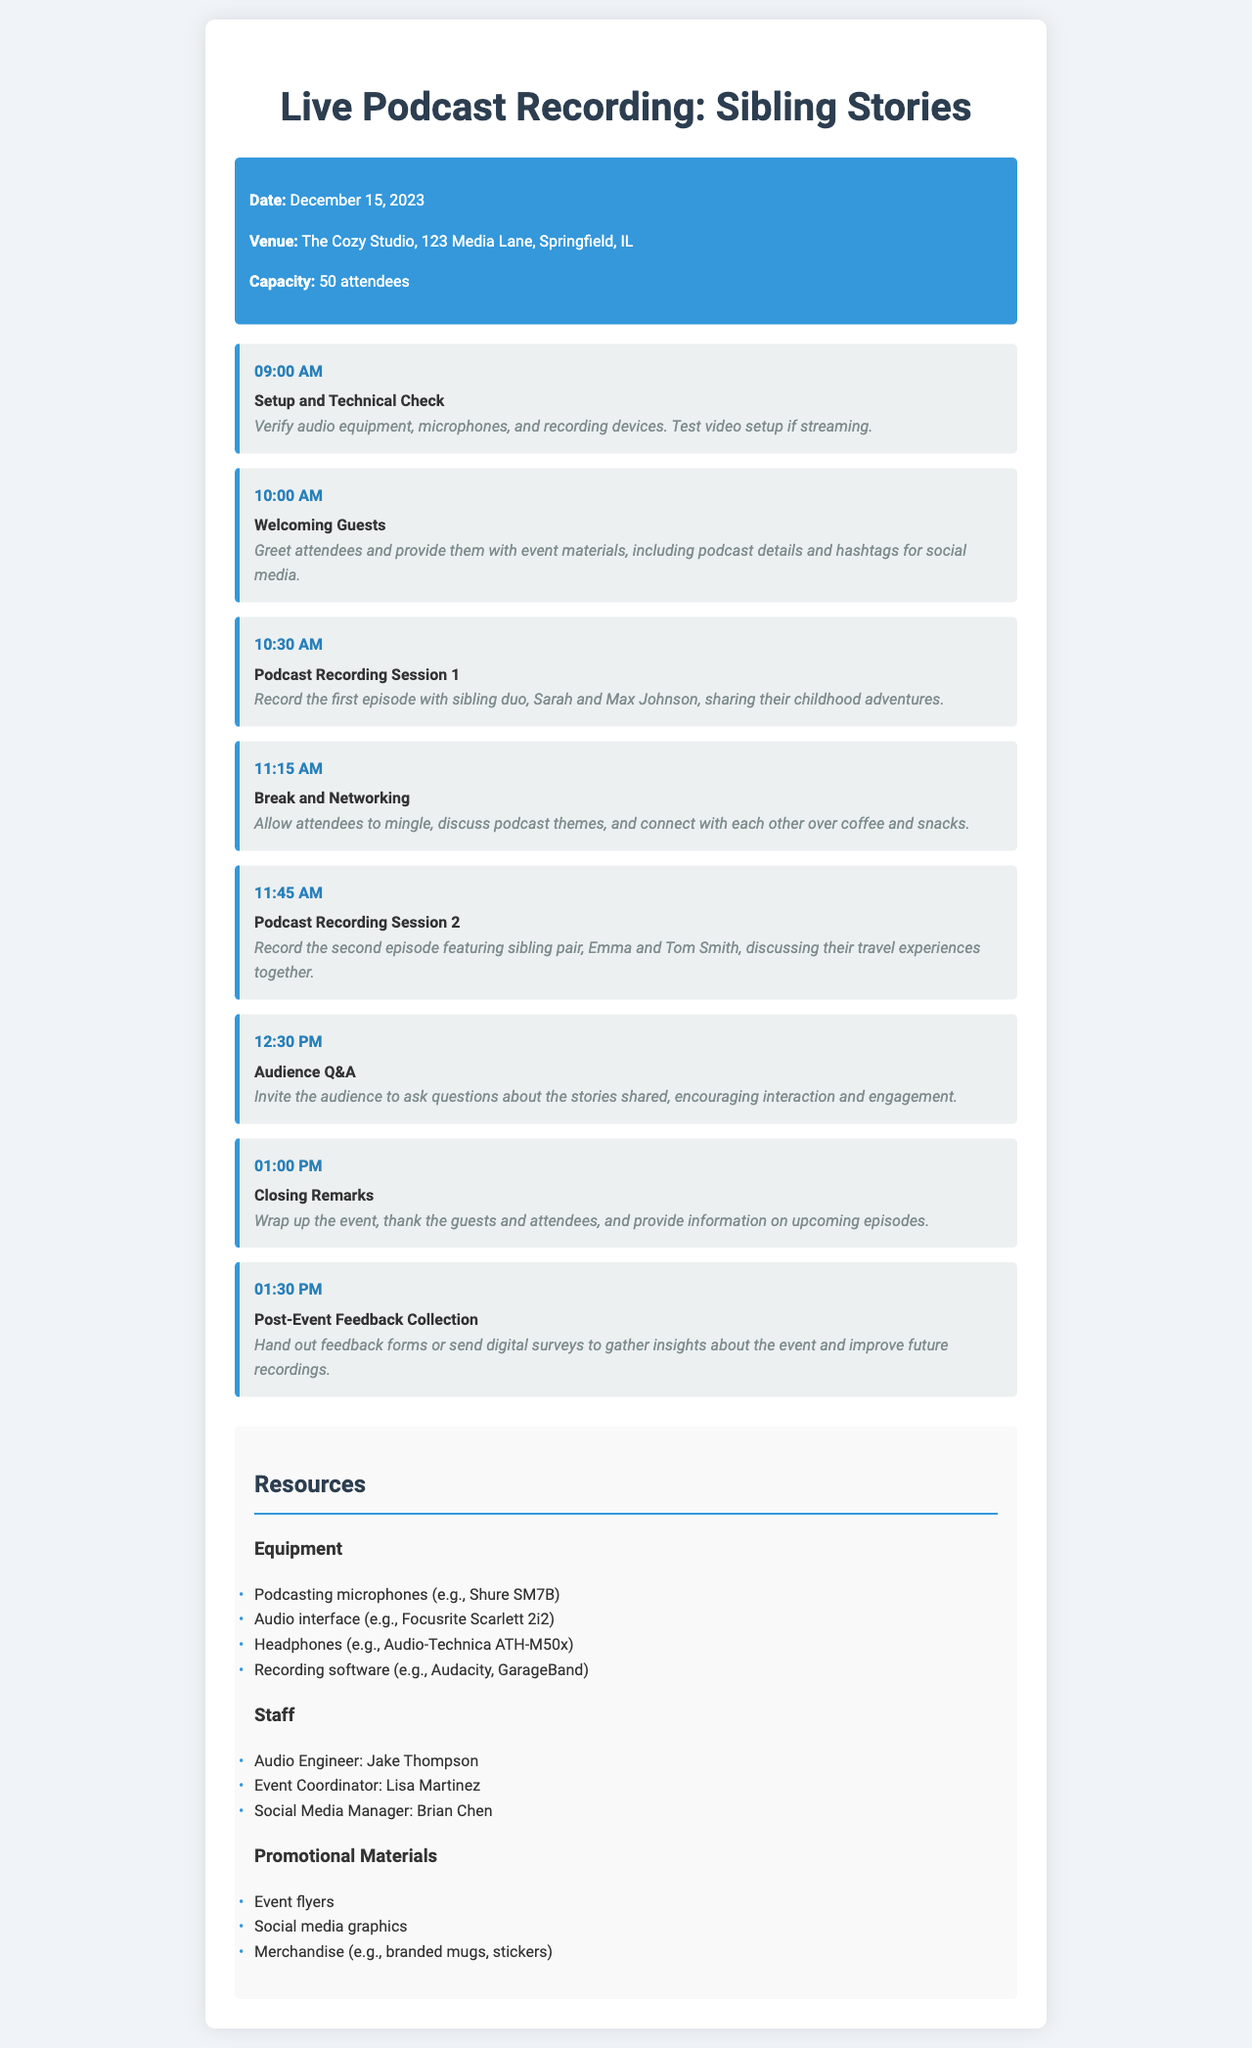What is the date of the live podcast recording? The date is specified in the event info section of the document.
Answer: December 15, 2023 Where is the venue located? The venue information is listed in the event info section.
Answer: The Cozy Studio, 123 Media Lane, Springfield, IL How many attendees can the venue accommodate? This information is provided under the event info section.
Answer: 50 attendees What is the first activity scheduled? The schedule details the activities in chronological order, starting from the beginning.
Answer: Setup and Technical Check What time does the Audience Q&A session start? The schedule lists the time for each activity in order.
Answer: 12:30 PM Who is the audio engineer for the event? Staff details are provided in the resources section of the document.
Answer: Jake Thompson What equipment is listed for recording? The resources section includes a list of equipment needed for the event.
Answer: Podcasting microphones (e.g., Shure SM7B) How long is the break and networking session? The schedule gives the duration of each session and breaks between recordings.
Answer: 30 minutes What type of materials will be provided to attendees? The event info specifies what attendees will receive upon arrival.
Answer: Event materials, including podcast details and hashtags for social media 